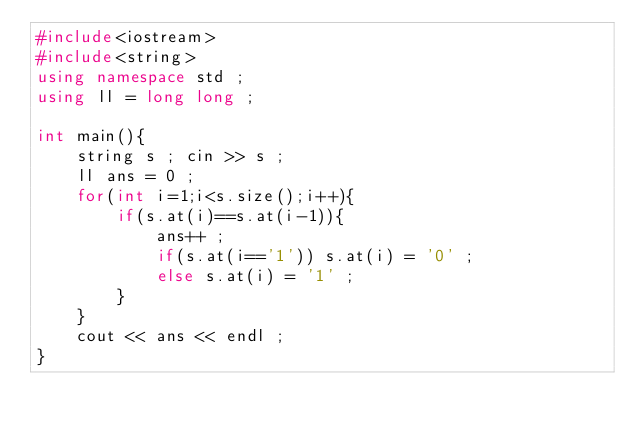Convert code to text. <code><loc_0><loc_0><loc_500><loc_500><_C++_>#include<iostream>
#include<string>
using namespace std ;
using ll = long long ;

int main(){
	string s ; cin >> s ;
	ll ans = 0 ;
	for(int i=1;i<s.size();i++){
		if(s.at(i)==s.at(i-1)){
			ans++ ;
			if(s.at(i=='1')) s.at(i) = '0' ;
			else s.at(i) = '1' ;
		}
	}
	cout << ans << endl ;
}
</code> 